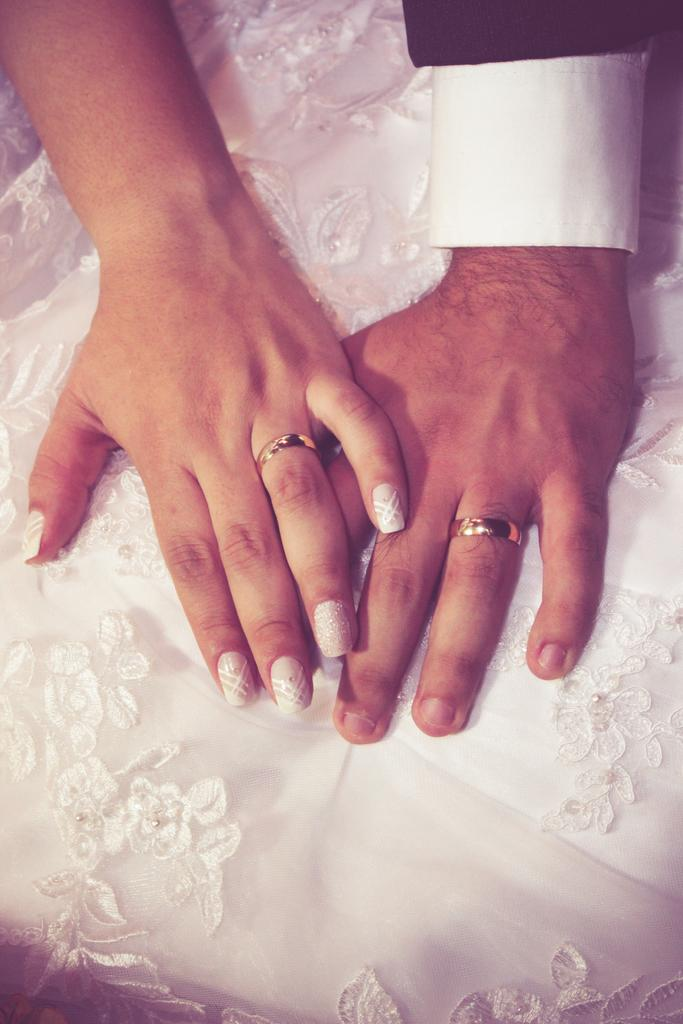What body part is visible in the image? There are hands visible in the image. Whom do the hands belong to? The hands belong to a person. What type of jewelry is worn on the fingers of the hands? There are rings on the fingers of the hands. What color is the cloth in the image? There is a white color cloth in the image. How does the person use the comb in the image? There is no comb present in the image. What type of shoes is the person wearing on their feet in the image? There is no mention of feet or shoes in the image; only hands and a white cloth are visible. 